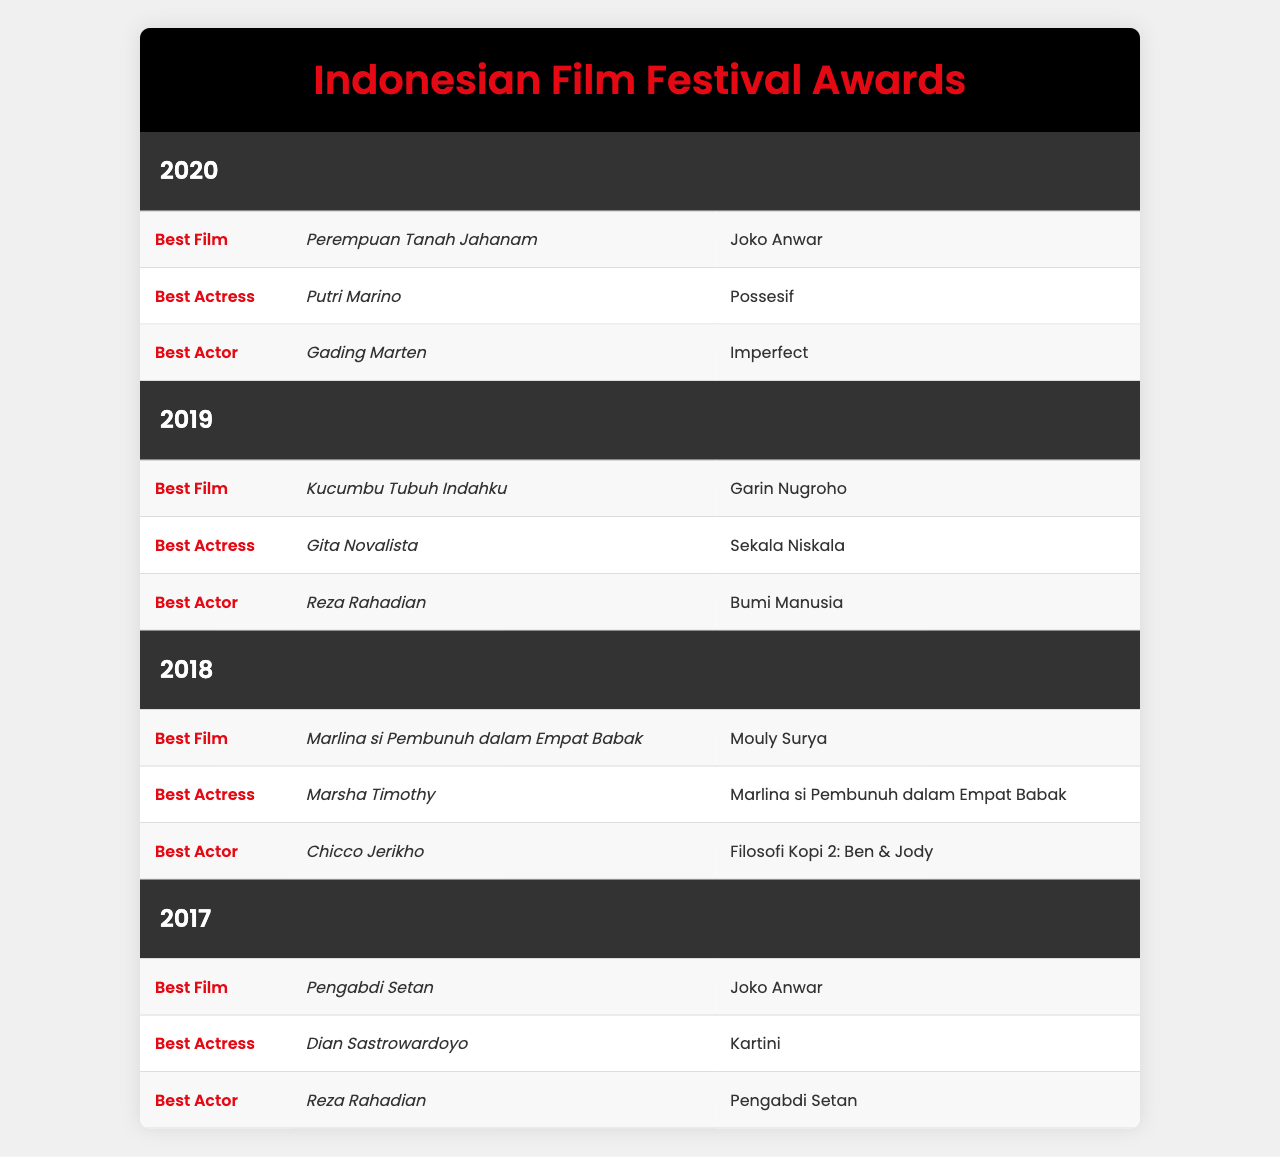What film won the Best Film award in 2020? From the table, under the category "Best Film" for the year 2020, the winner listed is "Perempuan Tanah Jahanam."
Answer: Perempuan Tanah Jahanam Who was awarded Best Actress in 2019? Looking at the year 2019, the "Best Actress" award winner is "Gita Novalista" for the film "Sekala Niskala."
Answer: Gita Novalista Which director won for Best Film in 2018? In 2018, the award for "Best Film" was won by "Marlina si Pembunuh dalam Empat Babak", directed by "Mouly Surya."
Answer: Mouly Surya Which actor won Best Actor in both 2017 and 2019? In 2017, "Reza Rahadian" won Best Actor for "Pengabdi Setan" and in 2019, he won again for "Bumi Manusia."
Answer: Reza Rahadian Was "Possesif" nominated for Best Film in 2020? "Possesif" is recognized under the "Best Actress" category for that year, but it was not nominated for Best Film.
Answer: No How many times has Joko Anwar directed a film that won Best Film based on the table? Joko Anwar directed "Pengabdi Setan" in 2017 and "Perempuan Tanah Jahanam" in 2020, which means he has two wins for Best Film.
Answer: Two times Which film won Best Actress and who was the winner in 2018? The table indicates that "Marsha Timothy" won Best Actress for the film "Marlina si Pembunuh dalam Empat Babak" in 2018.
Answer: Marsha Timothy In what year did both the Best Actress and Best Actor winners have films with the same name? The year 2018 features "Marsha Timothy" as Best Actress for "Marlina si Pembunuh dalam Empat Babak," and "Chicco Jerikho" won Best Actor for "Filosofi Kopi 2: Ben & Jody," so they did not share a film name. This question does not apply.
Answer: N/A Are there more male or female winners in the Best Actor and Best Actress categories combined? The winners are: Best Actress (Putri Marino, Gita Novalista, Marsha Timothy, Dian Sastrowardoyo - 4 females) and Best Actor (Gading Marten, Reza Rahadian, Chicco Jerikho - 3 males). Since 4 > 3, there are more female winners.
Answer: More female winners What was the most recent film that won the Best Film award? The most recent film mentioned in the table under the Best Film category is "Perempuan Tanah Jahanam," which won in 2020.
Answer: Perempuan Tanah Jahanam 